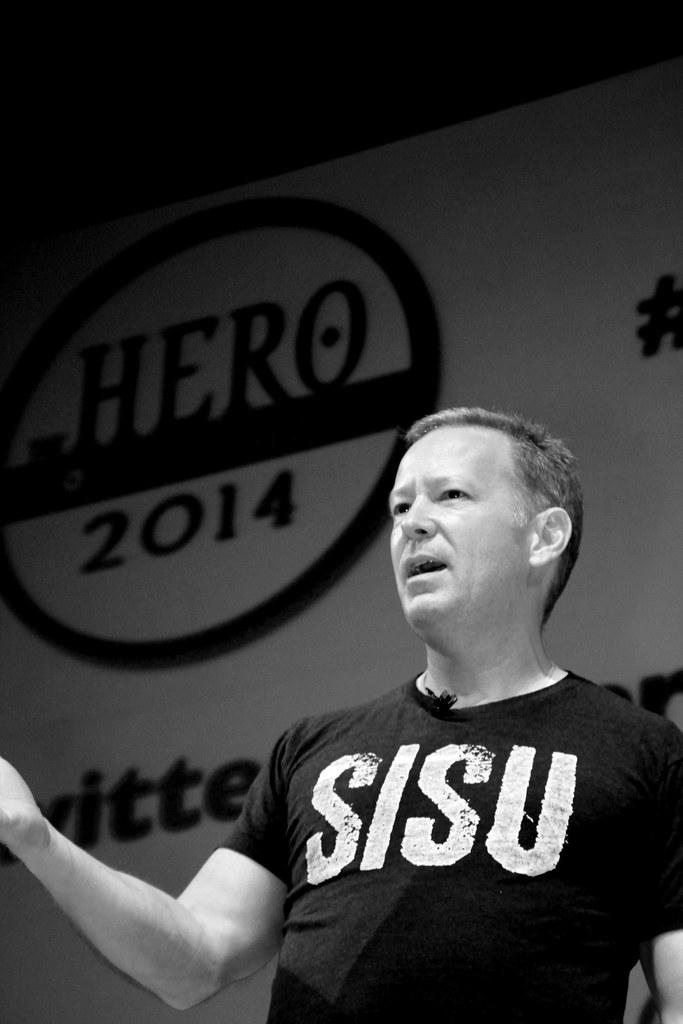What is on the man's shirt?
Offer a very short reply. Sisu. 